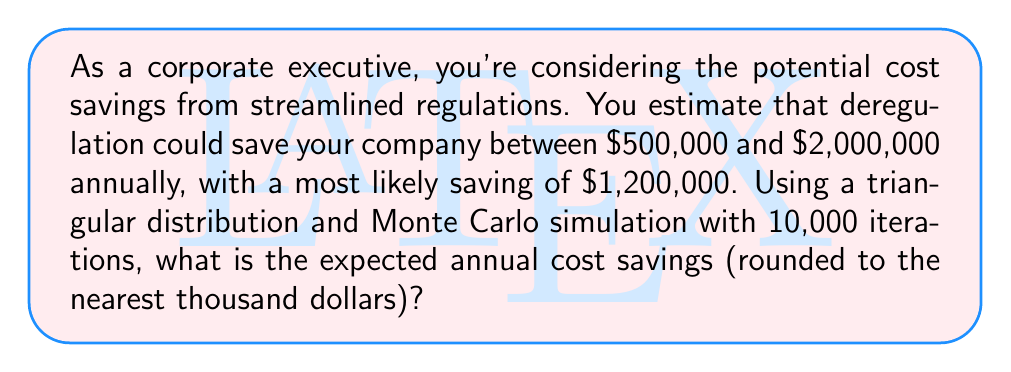What is the answer to this math problem? To solve this problem using Monte Carlo simulation with a triangular distribution, we'll follow these steps:

1) Set up the triangular distribution:
   Minimum (a) = $500,000
   Most likely (c) = $1,200,000
   Maximum (b) = $2,000,000

2) Generate 10,000 random numbers using the triangular distribution formula:

   For each iteration i (1 to 10,000):
   
   Generate a random number U between 0 and 1.
   
   If U < (c-a)/(b-a):
   $$X_i = a + \sqrt{U(b-a)(c-a)}$$
   
   Else:
   $$X_i = b - \sqrt{(1-U)(b-a)(b-c)}$$

3) Calculate the mean of these 10,000 generated values:
   $$\text{Expected Savings} = \frac{1}{10000} \sum_{i=1}^{10000} X_i$$

4) Round the result to the nearest thousand dollars.

In practice, this simulation would be run using a computer due to the large number of iterations. The result may vary slightly each time the simulation is run due to the random nature of the process, but it should converge to a value close to the analytical mean of a triangular distribution, which is:

$$\text{E}(X) = \frac{a + b + c}{3} = \frac{500000 + 2000000 + 1200000}{3} = 1233333.33$$

Rounding this to the nearest thousand gives us $1,233,000.

The Monte Carlo simulation result should be very close to this value.
Answer: $1,233,000 